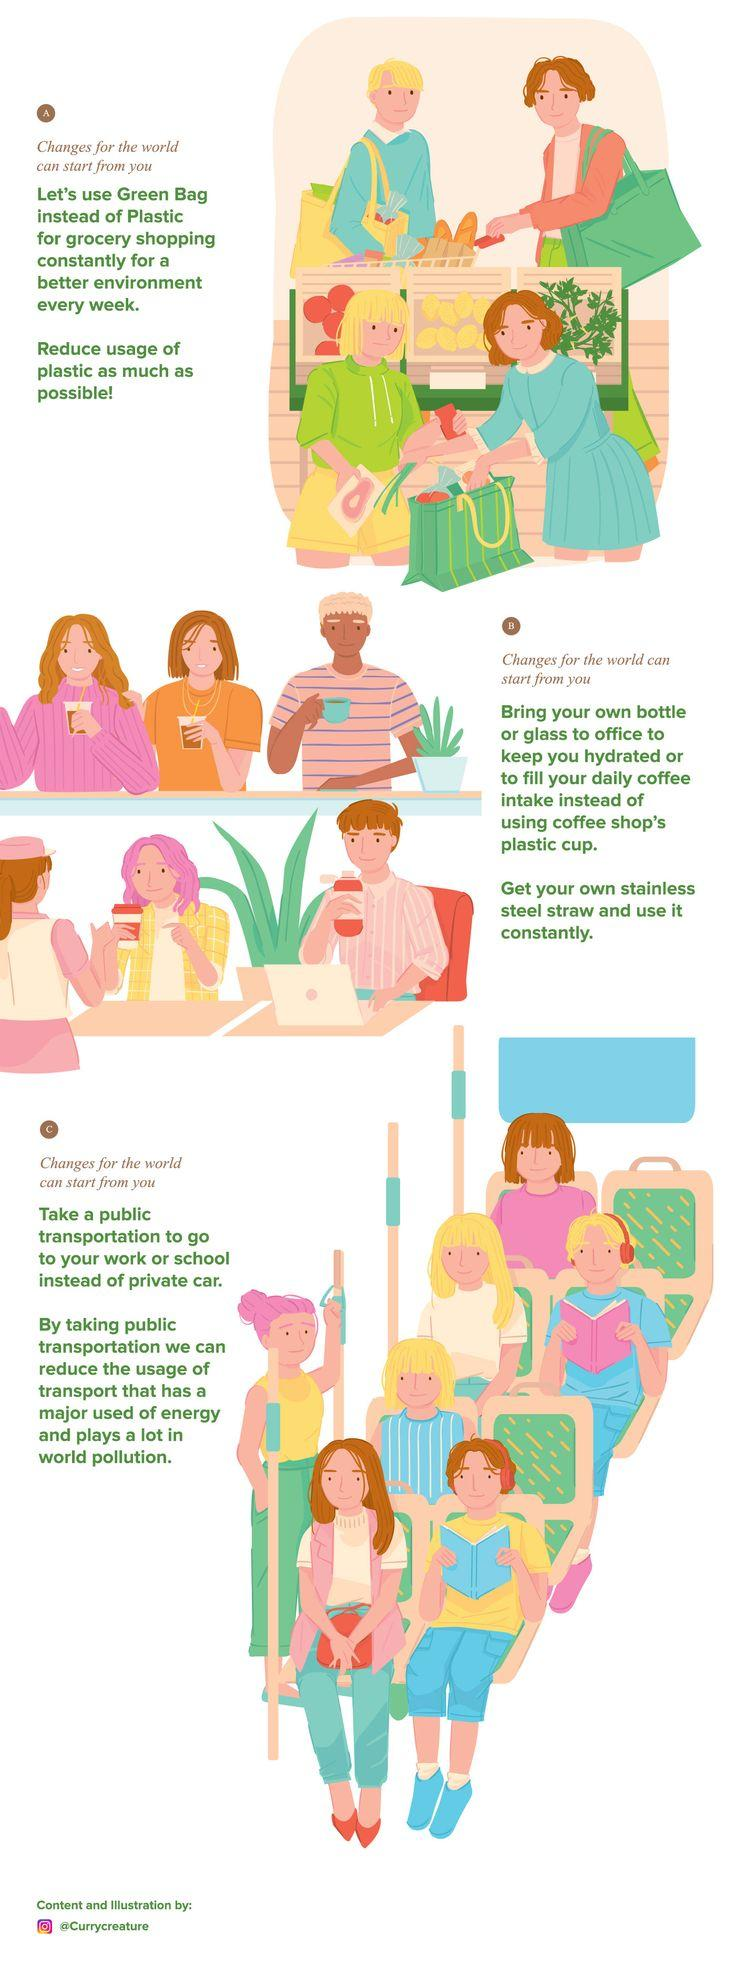Outline some significant characteristics in this image. There are 6 people sitting inside the bus. There are two people standing inside the bus. 